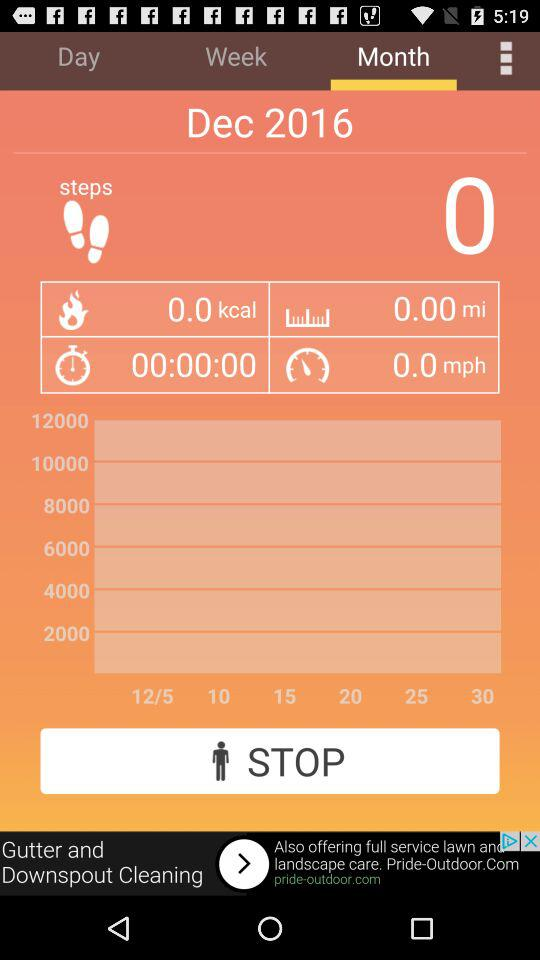How many steps have been completed? The completed steps is zero. 